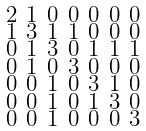Convert formula to latex. <formula><loc_0><loc_0><loc_500><loc_500>\begin{smallmatrix} 2 & 1 & 0 & 0 & 0 & 0 & 0 \\ 1 & 3 & 1 & 1 & 0 & 0 & 0 \\ 0 & 1 & 3 & 0 & 1 & 1 & 1 \\ 0 & 1 & 0 & 3 & 0 & 0 & 0 \\ 0 & 0 & 1 & 0 & 3 & 1 & 0 \\ 0 & 0 & 1 & 0 & 1 & 3 & 0 \\ 0 & 0 & 1 & 0 & 0 & 0 & 3 \end{smallmatrix}</formula> 